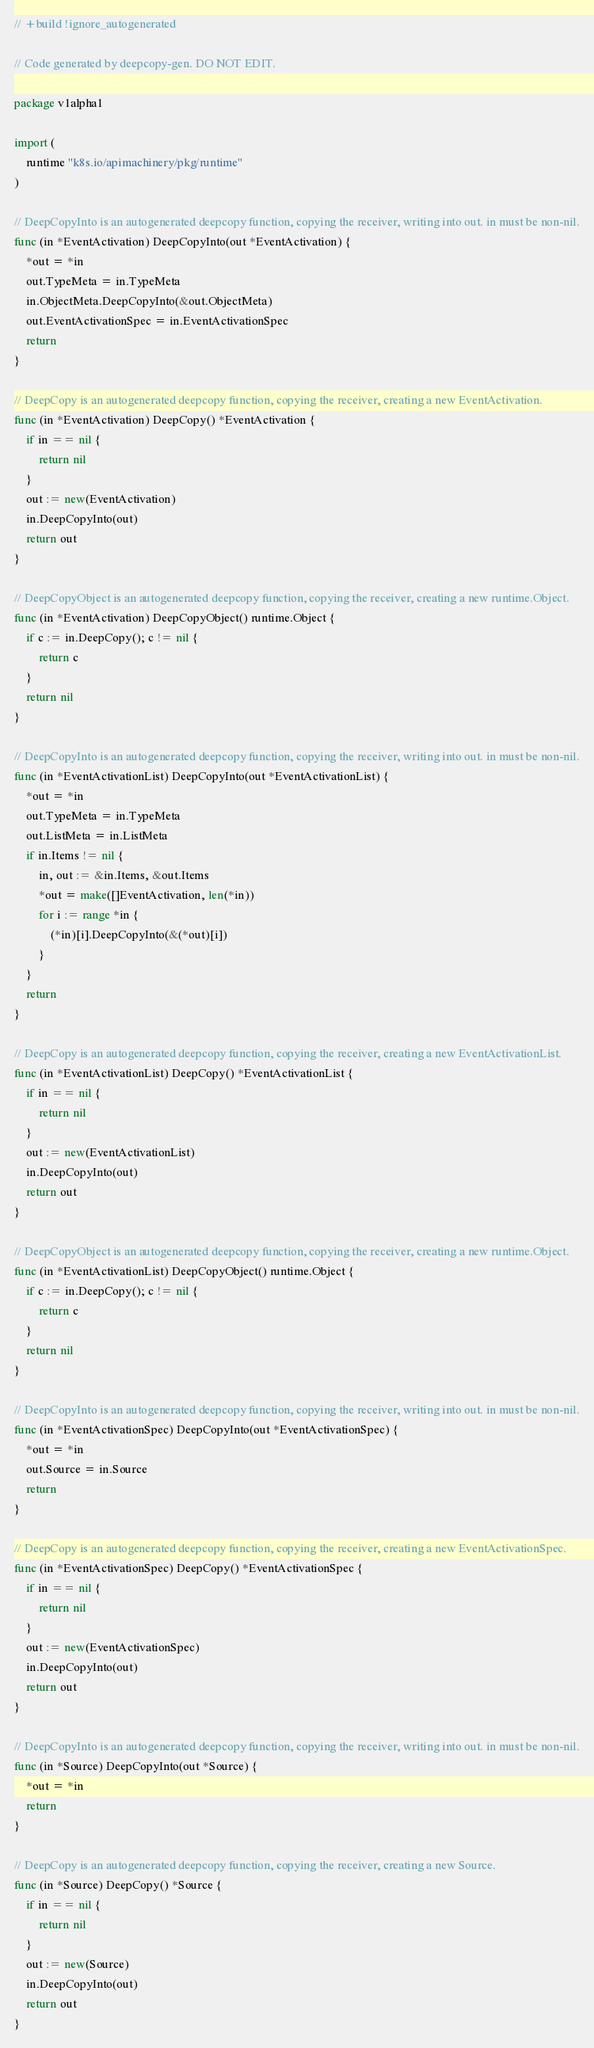Convert code to text. <code><loc_0><loc_0><loc_500><loc_500><_Go_>// +build !ignore_autogenerated

// Code generated by deepcopy-gen. DO NOT EDIT.

package v1alpha1

import (
	runtime "k8s.io/apimachinery/pkg/runtime"
)

// DeepCopyInto is an autogenerated deepcopy function, copying the receiver, writing into out. in must be non-nil.
func (in *EventActivation) DeepCopyInto(out *EventActivation) {
	*out = *in
	out.TypeMeta = in.TypeMeta
	in.ObjectMeta.DeepCopyInto(&out.ObjectMeta)
	out.EventActivationSpec = in.EventActivationSpec
	return
}

// DeepCopy is an autogenerated deepcopy function, copying the receiver, creating a new EventActivation.
func (in *EventActivation) DeepCopy() *EventActivation {
	if in == nil {
		return nil
	}
	out := new(EventActivation)
	in.DeepCopyInto(out)
	return out
}

// DeepCopyObject is an autogenerated deepcopy function, copying the receiver, creating a new runtime.Object.
func (in *EventActivation) DeepCopyObject() runtime.Object {
	if c := in.DeepCopy(); c != nil {
		return c
	}
	return nil
}

// DeepCopyInto is an autogenerated deepcopy function, copying the receiver, writing into out. in must be non-nil.
func (in *EventActivationList) DeepCopyInto(out *EventActivationList) {
	*out = *in
	out.TypeMeta = in.TypeMeta
	out.ListMeta = in.ListMeta
	if in.Items != nil {
		in, out := &in.Items, &out.Items
		*out = make([]EventActivation, len(*in))
		for i := range *in {
			(*in)[i].DeepCopyInto(&(*out)[i])
		}
	}
	return
}

// DeepCopy is an autogenerated deepcopy function, copying the receiver, creating a new EventActivationList.
func (in *EventActivationList) DeepCopy() *EventActivationList {
	if in == nil {
		return nil
	}
	out := new(EventActivationList)
	in.DeepCopyInto(out)
	return out
}

// DeepCopyObject is an autogenerated deepcopy function, copying the receiver, creating a new runtime.Object.
func (in *EventActivationList) DeepCopyObject() runtime.Object {
	if c := in.DeepCopy(); c != nil {
		return c
	}
	return nil
}

// DeepCopyInto is an autogenerated deepcopy function, copying the receiver, writing into out. in must be non-nil.
func (in *EventActivationSpec) DeepCopyInto(out *EventActivationSpec) {
	*out = *in
	out.Source = in.Source
	return
}

// DeepCopy is an autogenerated deepcopy function, copying the receiver, creating a new EventActivationSpec.
func (in *EventActivationSpec) DeepCopy() *EventActivationSpec {
	if in == nil {
		return nil
	}
	out := new(EventActivationSpec)
	in.DeepCopyInto(out)
	return out
}

// DeepCopyInto is an autogenerated deepcopy function, copying the receiver, writing into out. in must be non-nil.
func (in *Source) DeepCopyInto(out *Source) {
	*out = *in
	return
}

// DeepCopy is an autogenerated deepcopy function, copying the receiver, creating a new Source.
func (in *Source) DeepCopy() *Source {
	if in == nil {
		return nil
	}
	out := new(Source)
	in.DeepCopyInto(out)
	return out
}
</code> 